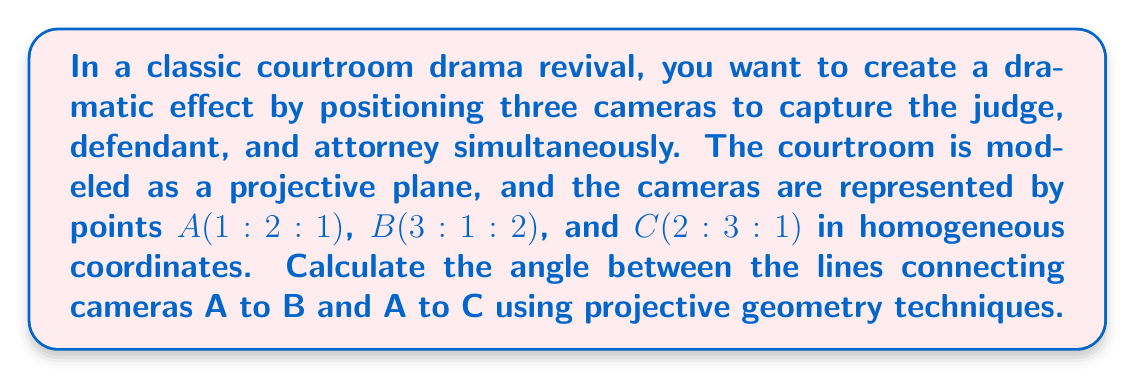Provide a solution to this math problem. To solve this problem, we'll follow these steps:

1) First, we need to find the lines connecting A to B and A to C. In projective geometry, we can do this by calculating the cross product of the points' coordinates.

   Line AB: $l_{AB} = A \times B = (1,2,1) \times (3,1,2)$
   $$l_{AB} = \begin{vmatrix}
   i & j & k \\
   1 & 2 & 1 \\
   3 & 1 & 2
   \end{vmatrix} = (3,1,-5)$$

   Line AC: $l_{AC} = A \times C = (1,2,1) \times (2,3,1)$
   $$l_{AC} = \begin{vmatrix}
   i & j & k \\
   1 & 2 & 1 \\
   2 & 3 & 1
   \end{vmatrix} = (-1,1,1)$$

2) The angle between two lines in projective geometry can be calculated using the formula:

   $$\cos \theta = \frac{|l_{AB} \cdot l_{AC}|}{\sqrt{(l_{AB} \cdot l_{AB})(l_{AC} \cdot l_{AC})}}$$

3) Let's calculate the dot products:
   
   $l_{AB} \cdot l_{AC} = 3(-1) + 1(1) + (-5)(1) = -7$
   
   $l_{AB} \cdot l_{AB} = 3^2 + 1^2 + (-5)^2 = 35$
   
   $l_{AC} \cdot l_{AC} = (-1)^2 + 1^2 + 1^2 = 3$

4) Now we can substitute these values into our formula:

   $$\cos \theta = \frac{|-7|}{\sqrt{35 \cdot 3}} = \frac{7}{\sqrt{105}}$$

5) To find the angle, we take the inverse cosine (arccos) of this value:

   $$\theta = \arccos(\frac{7}{\sqrt{105}})$$

6) Using a calculator or computer, we can evaluate this to get the angle in radians, and then convert to degrees:

   $$\theta \approx 0.9640 \text{ radians} \approx 55.23°$$
Answer: $55.23°$ 